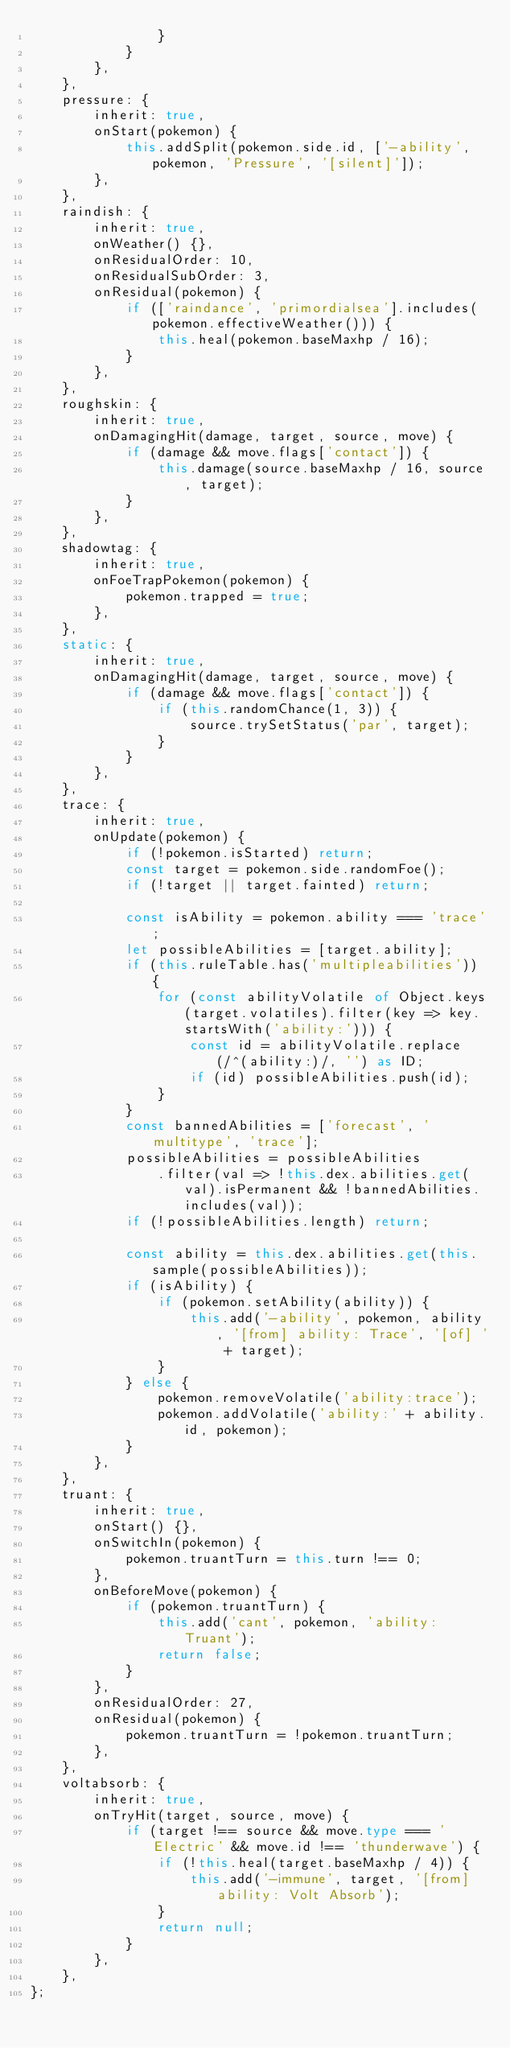<code> <loc_0><loc_0><loc_500><loc_500><_TypeScript_>				}
			}
		},
	},
	pressure: {
		inherit: true,
		onStart(pokemon) {
			this.addSplit(pokemon.side.id, ['-ability', pokemon, 'Pressure', '[silent]']);
		},
	},
	raindish: {
		inherit: true,
		onWeather() {},
		onResidualOrder: 10,
		onResidualSubOrder: 3,
		onResidual(pokemon) {
			if (['raindance', 'primordialsea'].includes(pokemon.effectiveWeather())) {
				this.heal(pokemon.baseMaxhp / 16);
			}
		},
	},
	roughskin: {
		inherit: true,
		onDamagingHit(damage, target, source, move) {
			if (damage && move.flags['contact']) {
				this.damage(source.baseMaxhp / 16, source, target);
			}
		},
	},
	shadowtag: {
		inherit: true,
		onFoeTrapPokemon(pokemon) {
			pokemon.trapped = true;
		},
	},
	static: {
		inherit: true,
		onDamagingHit(damage, target, source, move) {
			if (damage && move.flags['contact']) {
				if (this.randomChance(1, 3)) {
					source.trySetStatus('par', target);
				}
			}
		},
	},
	trace: {
		inherit: true,
		onUpdate(pokemon) {
			if (!pokemon.isStarted) return;
			const target = pokemon.side.randomFoe();
			if (!target || target.fainted) return;

			const isAbility = pokemon.ability === 'trace';
			let possibleAbilities = [target.ability];
			if (this.ruleTable.has('multipleabilities')) {
				for (const abilityVolatile of Object.keys(target.volatiles).filter(key => key.startsWith('ability:'))) {
					const id = abilityVolatile.replace(/^(ability:)/, '') as ID;
					if (id) possibleAbilities.push(id);
				}
			}
			const bannedAbilities = ['forecast', 'multitype', 'trace'];
			possibleAbilities = possibleAbilities
				.filter(val => !this.dex.abilities.get(val).isPermanent && !bannedAbilities.includes(val));
			if (!possibleAbilities.length) return;

			const ability = this.dex.abilities.get(this.sample(possibleAbilities));
			if (isAbility) {
				if (pokemon.setAbility(ability)) {
					this.add('-ability', pokemon, ability, '[from] ability: Trace', '[of] ' + target);
				}
			} else {
				pokemon.removeVolatile('ability:trace');
				pokemon.addVolatile('ability:' + ability.id, pokemon);
			}
		},
	},
	truant: {
		inherit: true,
		onStart() {},
		onSwitchIn(pokemon) {
			pokemon.truantTurn = this.turn !== 0;
		},
		onBeforeMove(pokemon) {
			if (pokemon.truantTurn) {
				this.add('cant', pokemon, 'ability: Truant');
				return false;
			}
		},
		onResidualOrder: 27,
		onResidual(pokemon) {
			pokemon.truantTurn = !pokemon.truantTurn;
		},
	},
	voltabsorb: {
		inherit: true,
		onTryHit(target, source, move) {
			if (target !== source && move.type === 'Electric' && move.id !== 'thunderwave') {
				if (!this.heal(target.baseMaxhp / 4)) {
					this.add('-immune', target, '[from] ability: Volt Absorb');
				}
				return null;
			}
		},
	},
};
</code> 